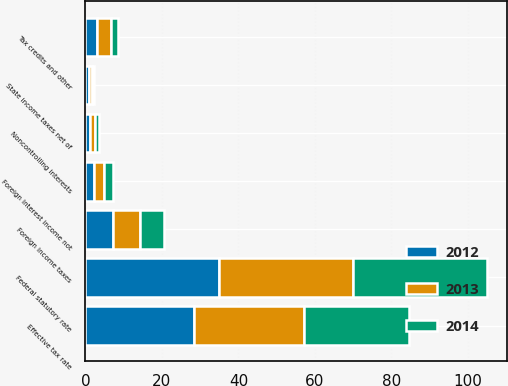<chart> <loc_0><loc_0><loc_500><loc_500><stacked_bar_chart><ecel><fcel>Federal statutory rate<fcel>State income taxes net of<fcel>Foreign income taxes<fcel>Foreign interest income not<fcel>Tax credits and other<fcel>Effective tax rate<fcel>Noncontrolling interests<nl><fcel>2012<fcel>35<fcel>0.9<fcel>7.2<fcel>2.1<fcel>3.1<fcel>28.5<fcel>1.2<nl><fcel>2013<fcel>35<fcel>0.9<fcel>7<fcel>2.8<fcel>3.7<fcel>28.6<fcel>1.2<nl><fcel>2014<fcel>35<fcel>0.5<fcel>6.3<fcel>2.2<fcel>1.8<fcel>27.6<fcel>1.2<nl></chart> 